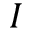Convert formula to latex. <formula><loc_0><loc_0><loc_500><loc_500>I</formula> 